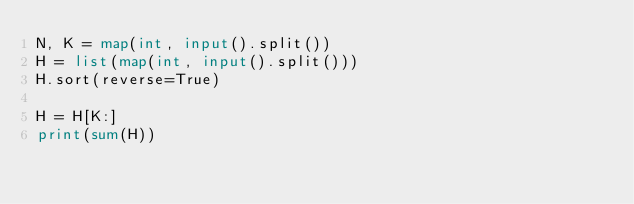<code> <loc_0><loc_0><loc_500><loc_500><_Python_>N, K = map(int, input().split())
H = list(map(int, input().split()))
H.sort(reverse=True)

H = H[K:]
print(sum(H))
</code> 